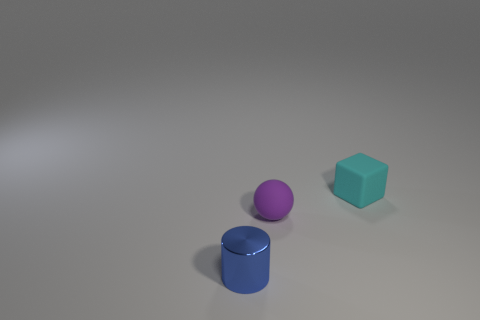Add 1 tiny shiny cylinders. How many objects exist? 4 Subtract all cylinders. How many objects are left? 2 Subtract 0 brown blocks. How many objects are left? 3 Subtract all small cylinders. Subtract all large yellow shiny blocks. How many objects are left? 2 Add 1 small cyan things. How many small cyan things are left? 2 Add 2 small metal things. How many small metal things exist? 3 